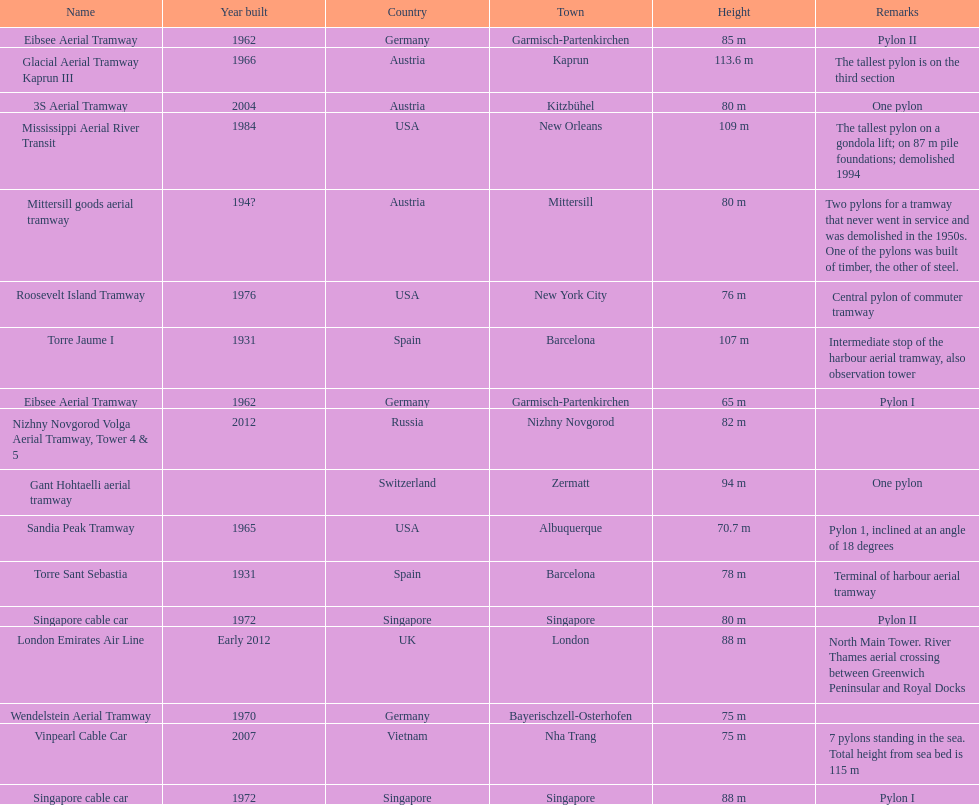What is the total number of tallest pylons in austria? 3. 